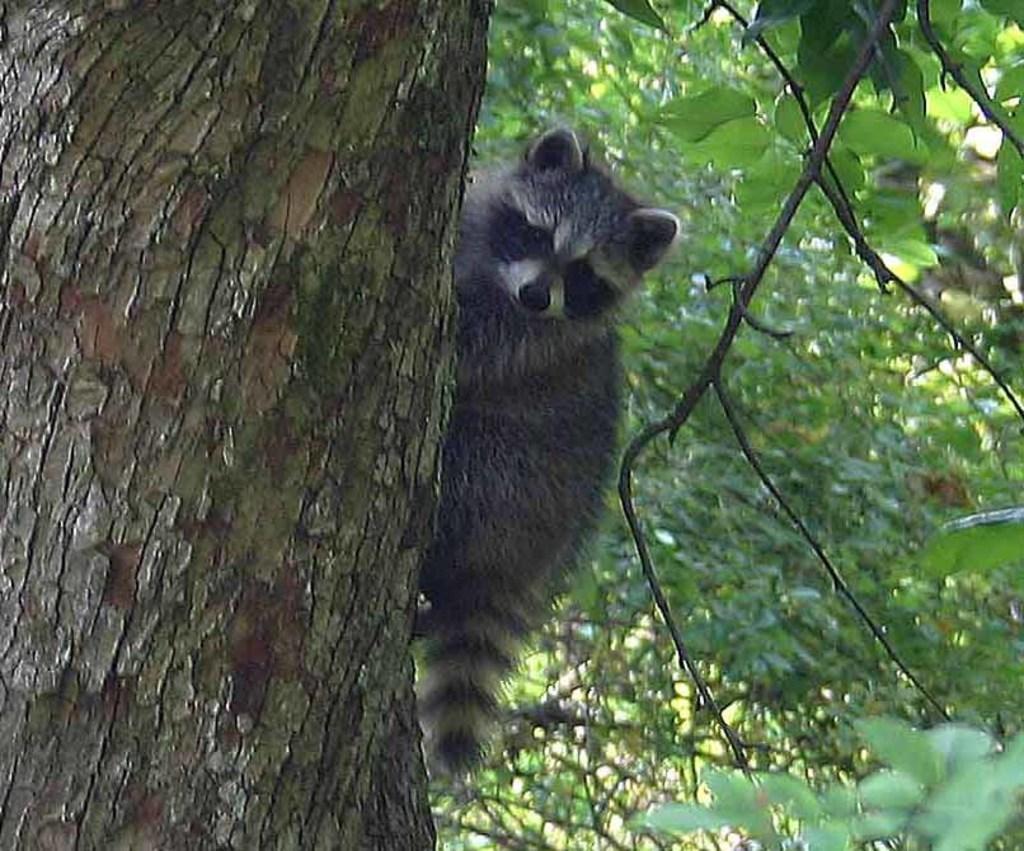Can you describe this image briefly? In the image in the center, we can see one animal, which is in black color. In the background we can see trees. 